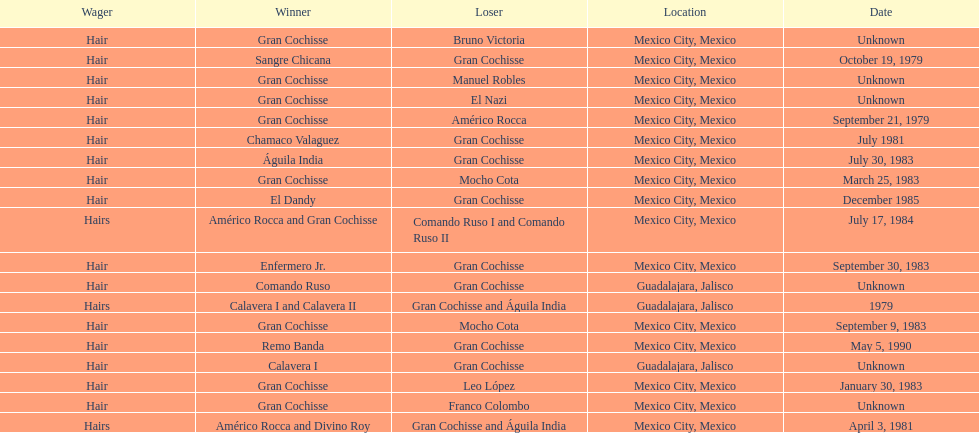How many winners were there before bruno victoria lost? 3. 